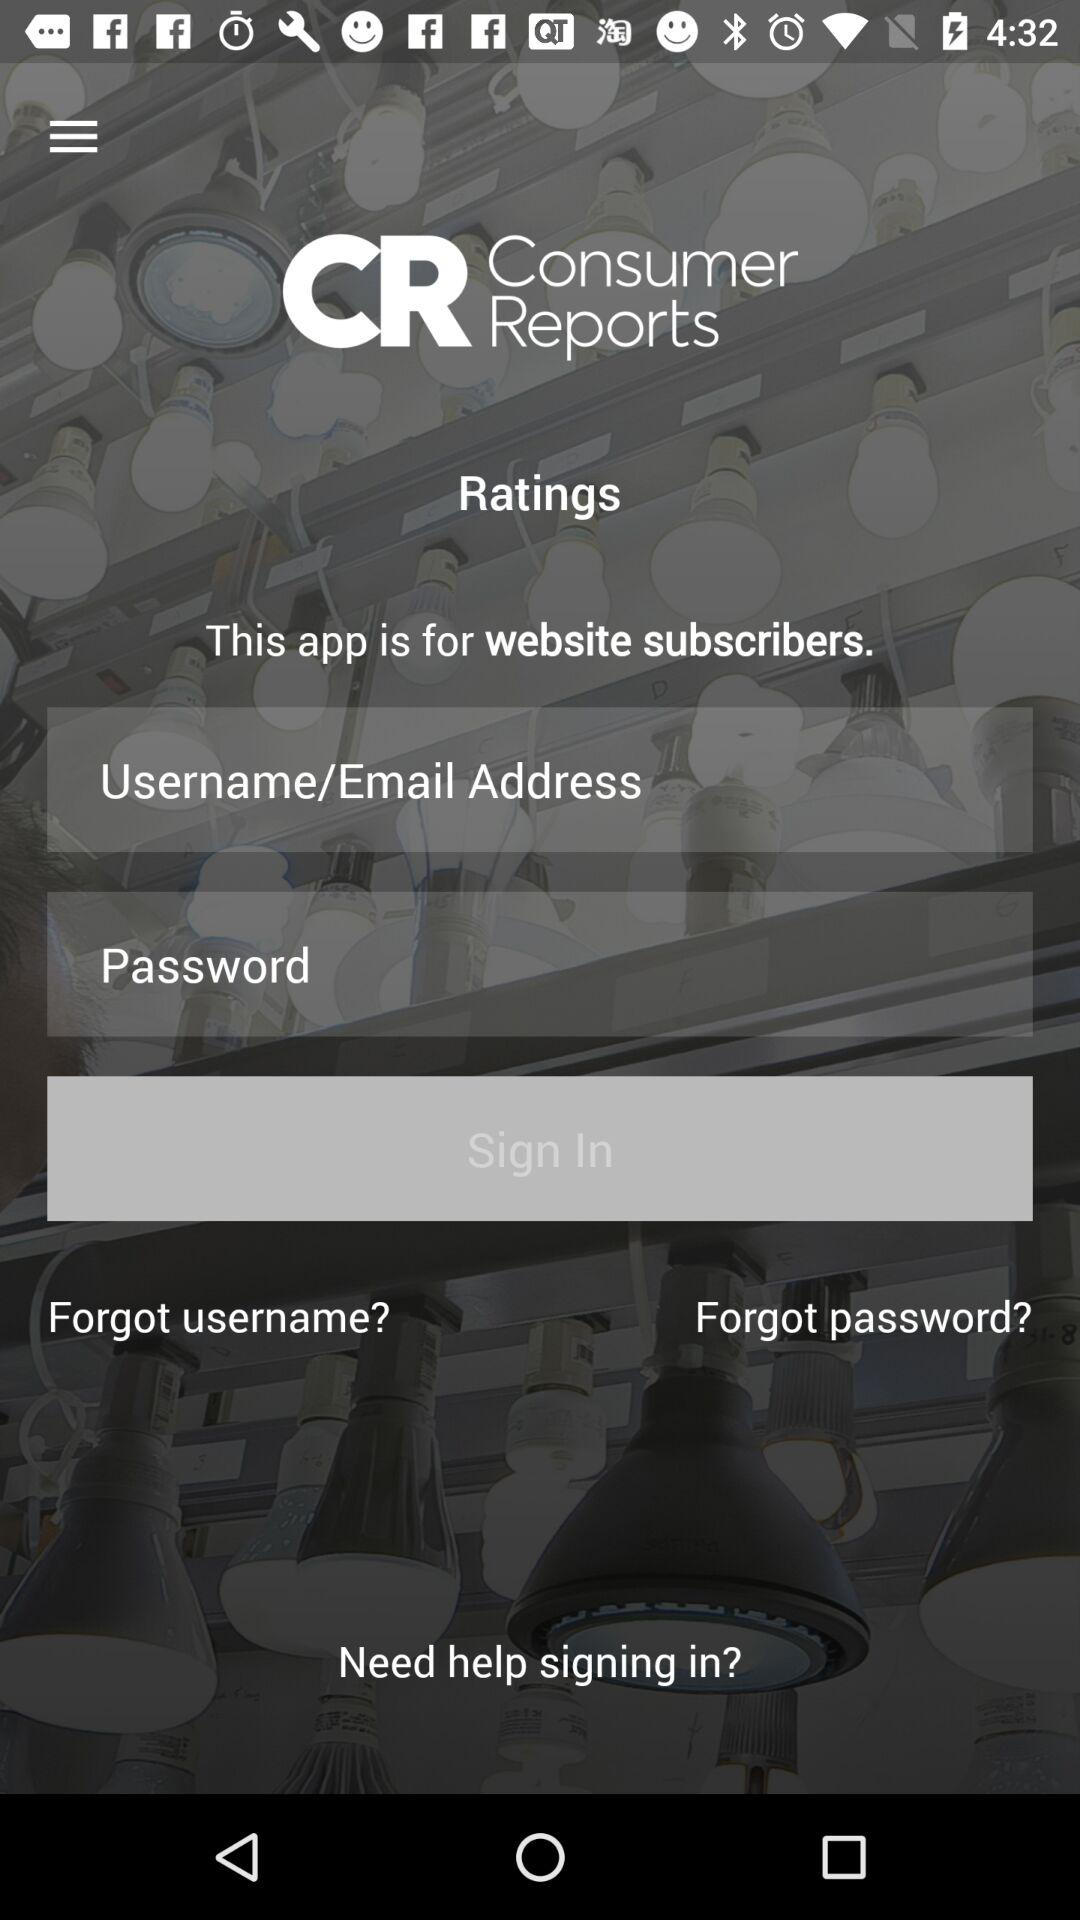How long is the password?
When the provided information is insufficient, respond with <no answer>. <no answer> 